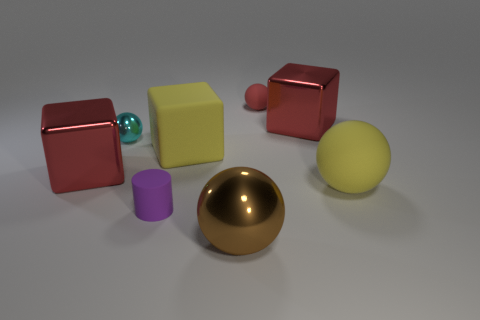Are there the same number of cubes on the right side of the purple rubber cylinder and rubber cylinders?
Keep it short and to the point. No. Is the shape of the large yellow thing to the left of the large brown object the same as  the red rubber thing?
Make the answer very short. No. What is the shape of the tiny metallic thing?
Your answer should be very brief. Sphere. The yellow object behind the yellow object in front of the big red cube that is in front of the cyan metal sphere is made of what material?
Ensure brevity in your answer.  Rubber. There is a sphere that is the same color as the large matte block; what material is it?
Provide a short and direct response. Rubber. What number of objects are rubber blocks or purple objects?
Offer a terse response. 2. Is the material of the tiny purple object on the left side of the brown ball the same as the big brown sphere?
Keep it short and to the point. No. How many objects are red things on the left side of the tiny cyan metal ball or green metallic spheres?
Your answer should be very brief. 1. The large sphere that is made of the same material as the tiny purple cylinder is what color?
Keep it short and to the point. Yellow. Is there a purple metallic ball of the same size as the red matte object?
Ensure brevity in your answer.  No. 